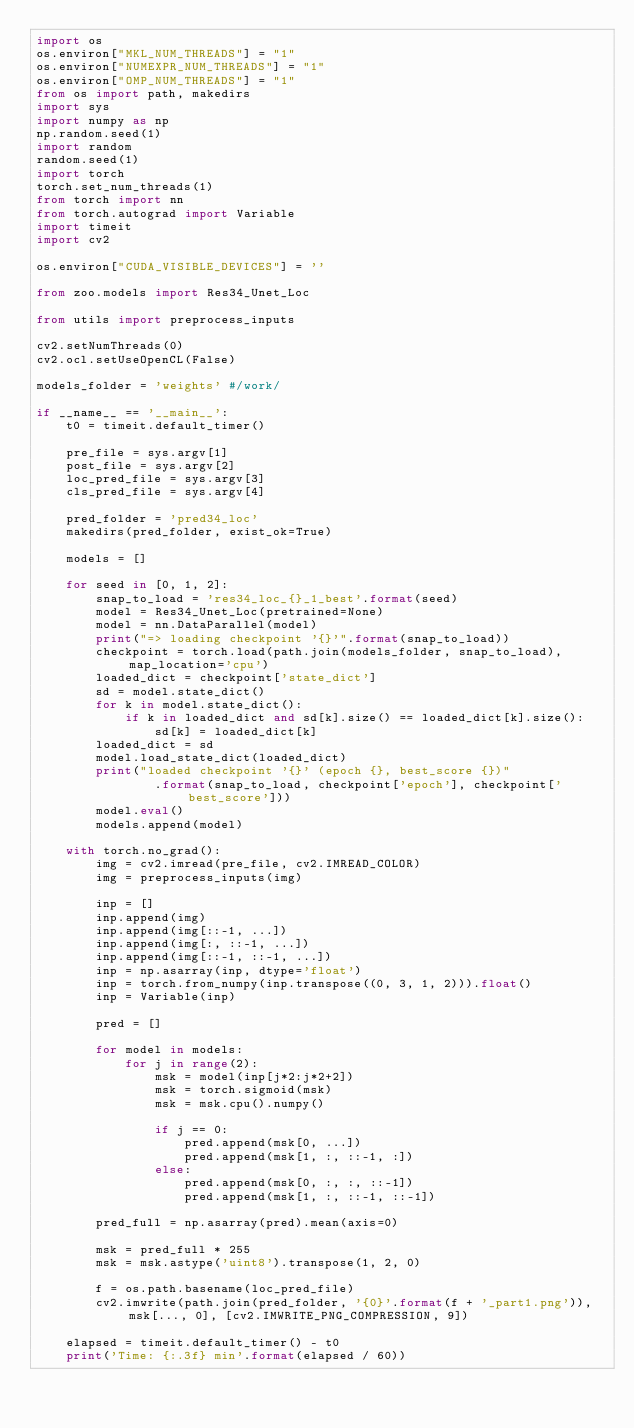Convert code to text. <code><loc_0><loc_0><loc_500><loc_500><_Python_>import os
os.environ["MKL_NUM_THREADS"] = "1" 
os.environ["NUMEXPR_NUM_THREADS"] = "1" 
os.environ["OMP_NUM_THREADS"] = "1"
from os import path, makedirs
import sys
import numpy as np
np.random.seed(1)
import random
random.seed(1)
import torch
torch.set_num_threads(1)
from torch import nn
from torch.autograd import Variable
import timeit
import cv2

os.environ["CUDA_VISIBLE_DEVICES"] = ''

from zoo.models import Res34_Unet_Loc

from utils import preprocess_inputs

cv2.setNumThreads(0)
cv2.ocl.setUseOpenCL(False)

models_folder = 'weights' #/work/

if __name__ == '__main__':
    t0 = timeit.default_timer()

    pre_file = sys.argv[1]
    post_file = sys.argv[2]
    loc_pred_file = sys.argv[3]
    cls_pred_file = sys.argv[4]

    pred_folder = 'pred34_loc'
    makedirs(pred_folder, exist_ok=True)

    models = []

    for seed in [0, 1, 2]:
        snap_to_load = 'res34_loc_{}_1_best'.format(seed)
        model = Res34_Unet_Loc(pretrained=None)
        model = nn.DataParallel(model)
        print("=> loading checkpoint '{}'".format(snap_to_load))
        checkpoint = torch.load(path.join(models_folder, snap_to_load), map_location='cpu')
        loaded_dict = checkpoint['state_dict']
        sd = model.state_dict()
        for k in model.state_dict():
            if k in loaded_dict and sd[k].size() == loaded_dict[k].size():
                sd[k] = loaded_dict[k]
        loaded_dict = sd
        model.load_state_dict(loaded_dict)
        print("loaded checkpoint '{}' (epoch {}, best_score {})"
                .format(snap_to_load, checkpoint['epoch'], checkpoint['best_score']))
        model.eval()
        models.append(model)

    with torch.no_grad():
        img = cv2.imread(pre_file, cv2.IMREAD_COLOR)
        img = preprocess_inputs(img)

        inp = []
        inp.append(img)
        inp.append(img[::-1, ...])
        inp.append(img[:, ::-1, ...])
        inp.append(img[::-1, ::-1, ...])
        inp = np.asarray(inp, dtype='float')
        inp = torch.from_numpy(inp.transpose((0, 3, 1, 2))).float()
        inp = Variable(inp)

        pred = []
        
        for model in models:
            for j in range(2):
                msk = model(inp[j*2:j*2+2])
                msk = torch.sigmoid(msk)
                msk = msk.cpu().numpy()
                
                if j == 0:
                    pred.append(msk[0, ...])
                    pred.append(msk[1, :, ::-1, :])
                else:
                    pred.append(msk[0, :, :, ::-1])
                    pred.append(msk[1, :, ::-1, ::-1])

        pred_full = np.asarray(pred).mean(axis=0)
        
        msk = pred_full * 255
        msk = msk.astype('uint8').transpose(1, 2, 0)

        f = os.path.basename(loc_pred_file)
        cv2.imwrite(path.join(pred_folder, '{0}'.format(f + '_part1.png')), msk[..., 0], [cv2.IMWRITE_PNG_COMPRESSION, 9])

    elapsed = timeit.default_timer() - t0
    print('Time: {:.3f} min'.format(elapsed / 60))</code> 